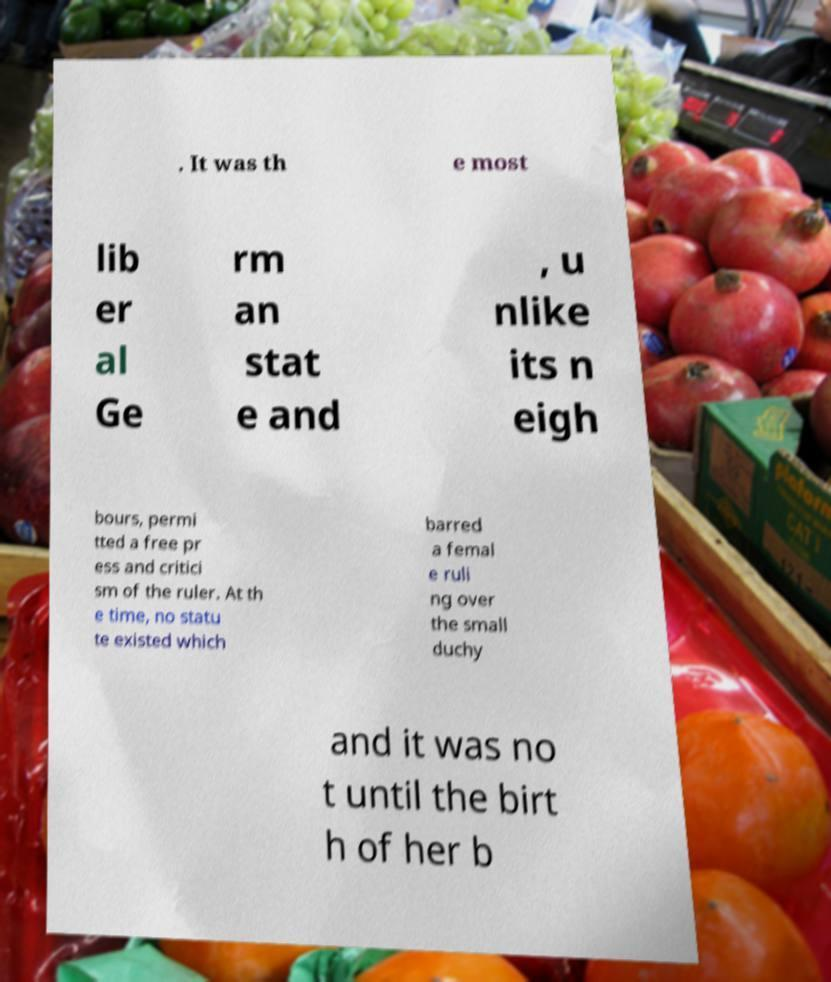I need the written content from this picture converted into text. Can you do that? . It was th e most lib er al Ge rm an stat e and , u nlike its n eigh bours, permi tted a free pr ess and critici sm of the ruler. At th e time, no statu te existed which barred a femal e ruli ng over the small duchy and it was no t until the birt h of her b 